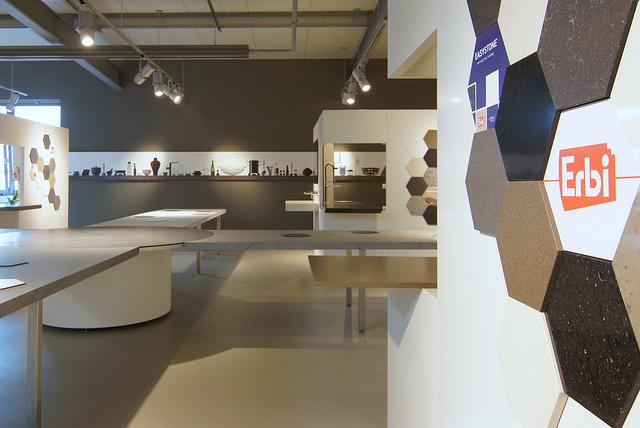Is the wall black?
Short answer required. No. What shape is featured prominently in the decor?
Give a very brief answer. Octagon. Is there overhead lighting in the picture?
Be succinct. Yes. 